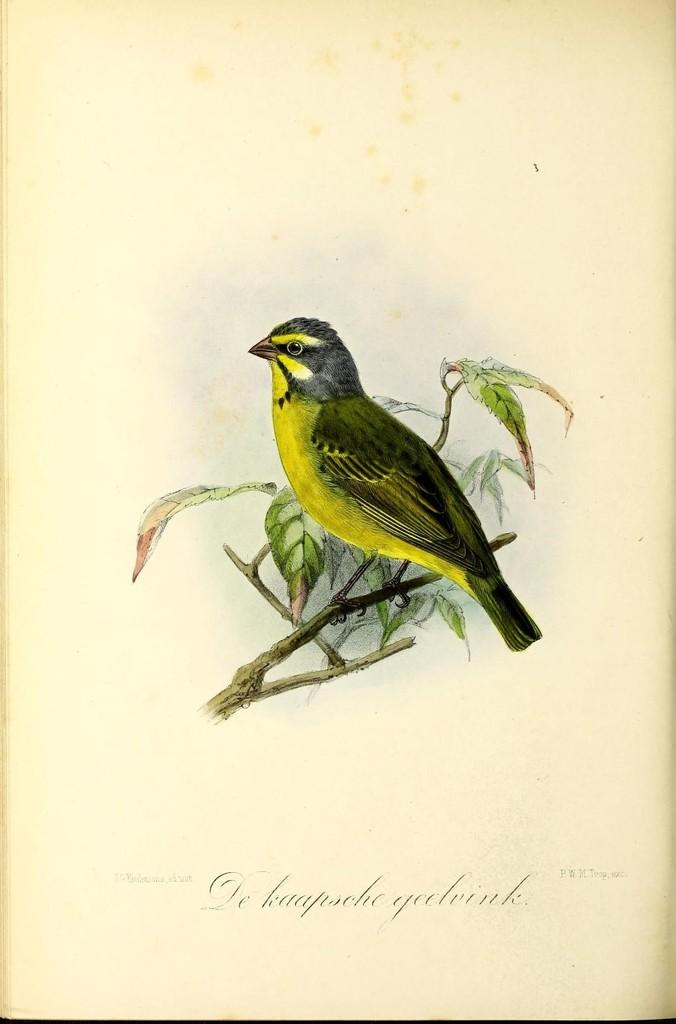What type of animal can be seen in the image? There is a bird in the image. Where is the bird positioned in the image? The bird is standing on a stem. What other elements are present in the image besides the bird? There are leaves in the image. What can be found at the bottom portion of the image? There is text or writing at the bottom portion of the image. How does the bird feel about the rainstorm in the image? There is no rainstorm present in the image, so it is not possible to determine how the bird feels about it. 